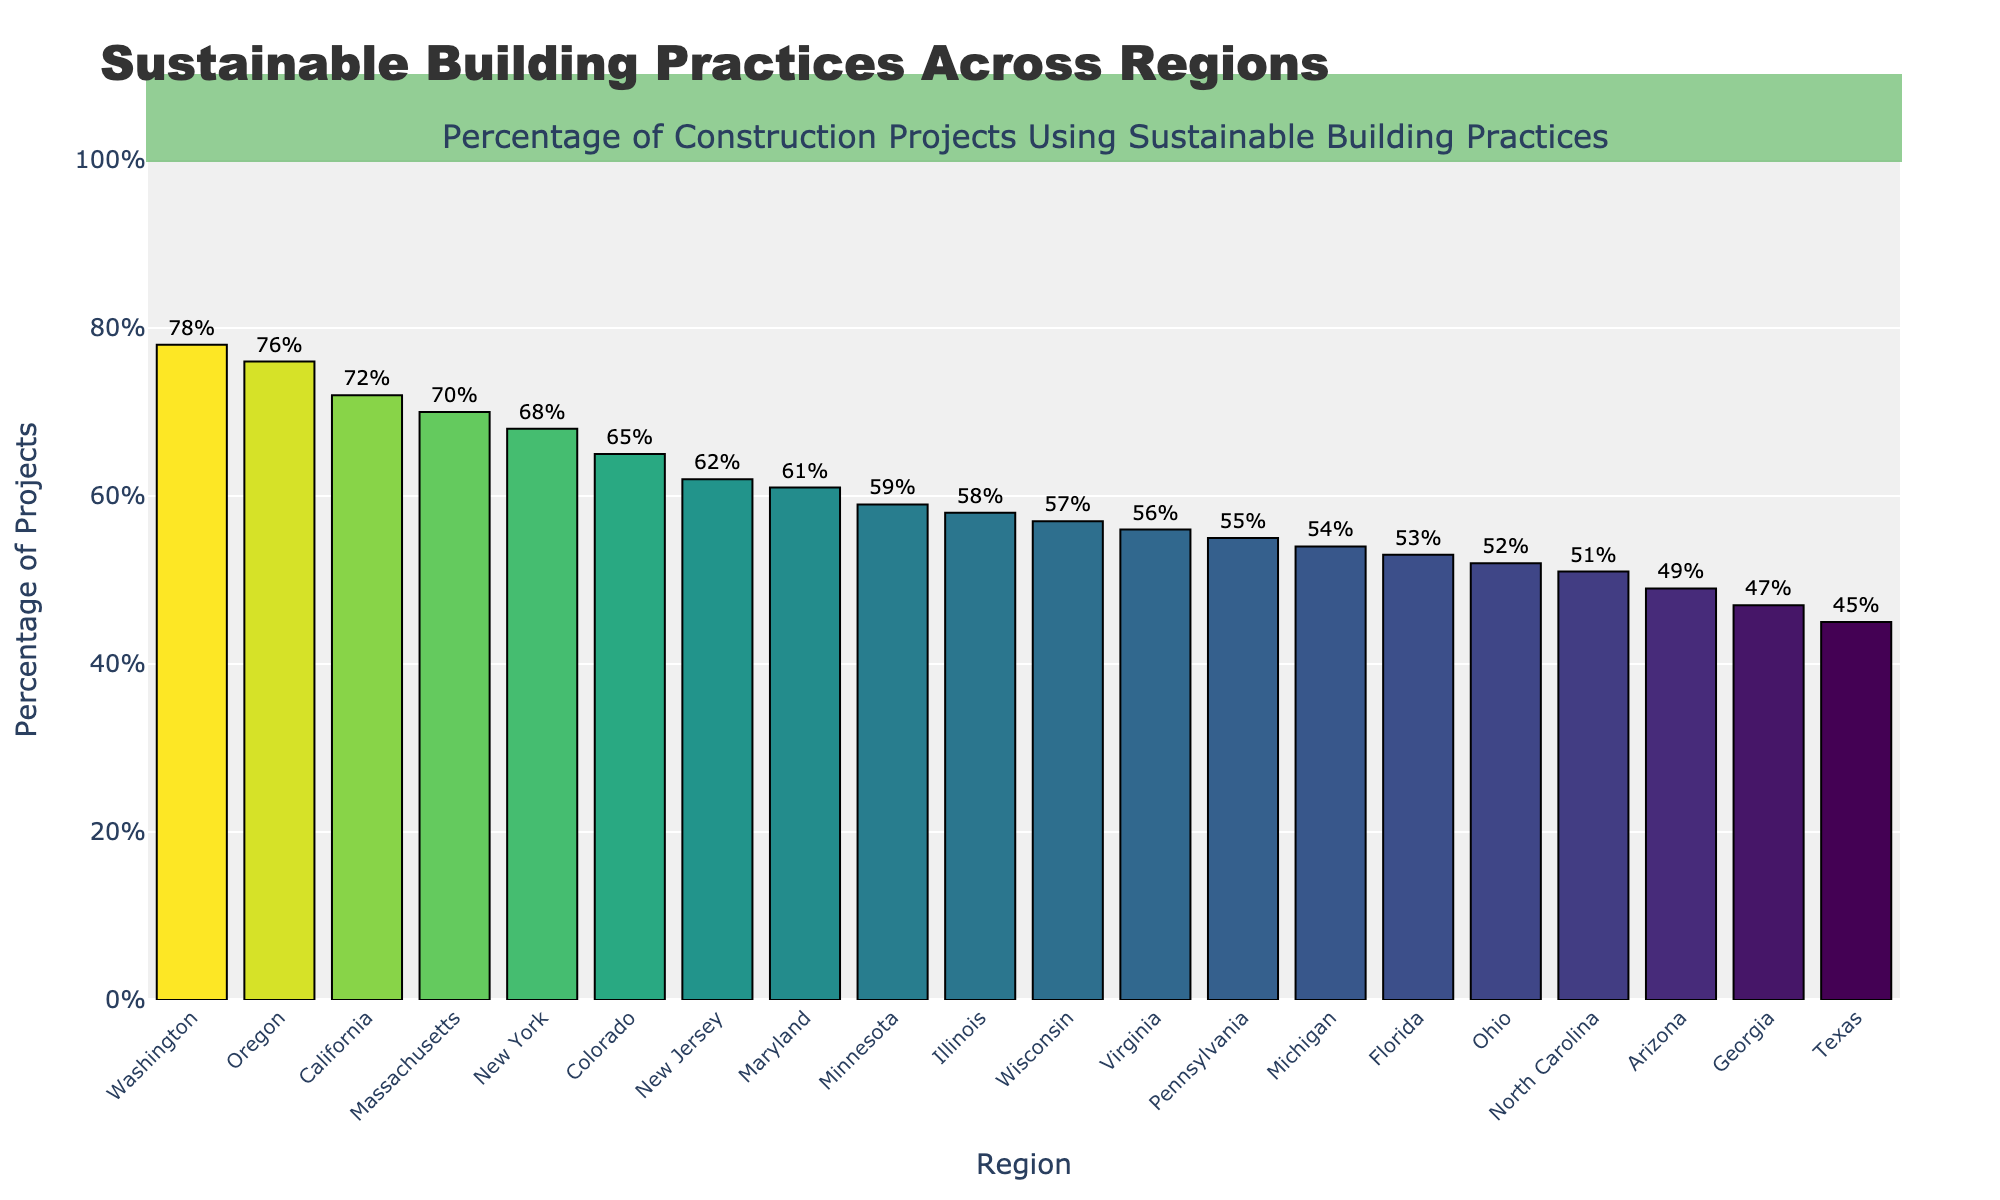Which region has the highest percentage of construction projects using sustainable building practices? To determine which region has the highest percentage, look for the tallest bar in the chart. Washington has the highest bar.
Answer: Washington Which region has the lowest percentage of construction projects using sustainable building practices? To determine which region has the lowest percentage, look for the shortest bar in the chart. Texas has the lowest bar.
Answer: Texas What is the difference in percentage between California and New York? Find the bars for California and New York, note their percentages (California: 72%, New York: 68%), and subtract the smaller percentage from the larger one (72 - 68 = 4).
Answer: 4% What is the average percentage of the top 5 regions in sustainable building practices? Identify the top 5 regions by percentage (Washington: 78%, Oregon: 76%, California: 72%, Massachusetts: 70%, New York: 68%), then sum their percentages and divide by 5 ((78 + 76 + 72 + 70 + 68) / 5 = 72.8).
Answer: 72.8% How many regions have percentages above 60%? Count the number of regions with bars higher than the 60% mark. These regions are Washington, Oregon, California, Massachusetts, New York, Colorado, and New Jersey, making a total of 7 regions.
Answer: 7 regions Which two regions have percentages closest to each other? Look for bars with similar heights. Colorado (65%) and New Jersey (62%) are closest, as their difference is only 3%.
Answer: Colorado and New Jersey What is the sum of the percentages for Illinois, Arizona, and North Carolina? Add the percentages of Illinois (58%), Arizona (49%), and North Carolina (51%) (58 + 49 + 51 = 158).
Answer: 158% Is the percentage of sustainable building practices in Washington more than double that of Texas? Compare Washington (78%) and Texas (45%) by checking if Washington's percentage is more than double Texas's percentage (2 * 45 = 90, and 78 is less than 90).
Answer: No Among the listed regions, which have percentages between 50% and 60%? Identify the regions with bars between the 50% and 60% marks: Illinois (58%), North Carolina (51%), Virginia (56%), Michigan (54%), Minnesota (59%), Wisconsin (57%), Ohio (52%), and Pennsylvania (55%).
Answer: Illinois, North Carolina, Virginia, Michigan, Minnesota, Wisconsin, Ohio, and Pennsylvania What is the range of percentages across all the regions? Find the highest percentage (Washington: 78%) and the lowest percentage (Texas: 45%), then subtract the lowest from the highest (78 - 45 = 33).
Answer: 33 